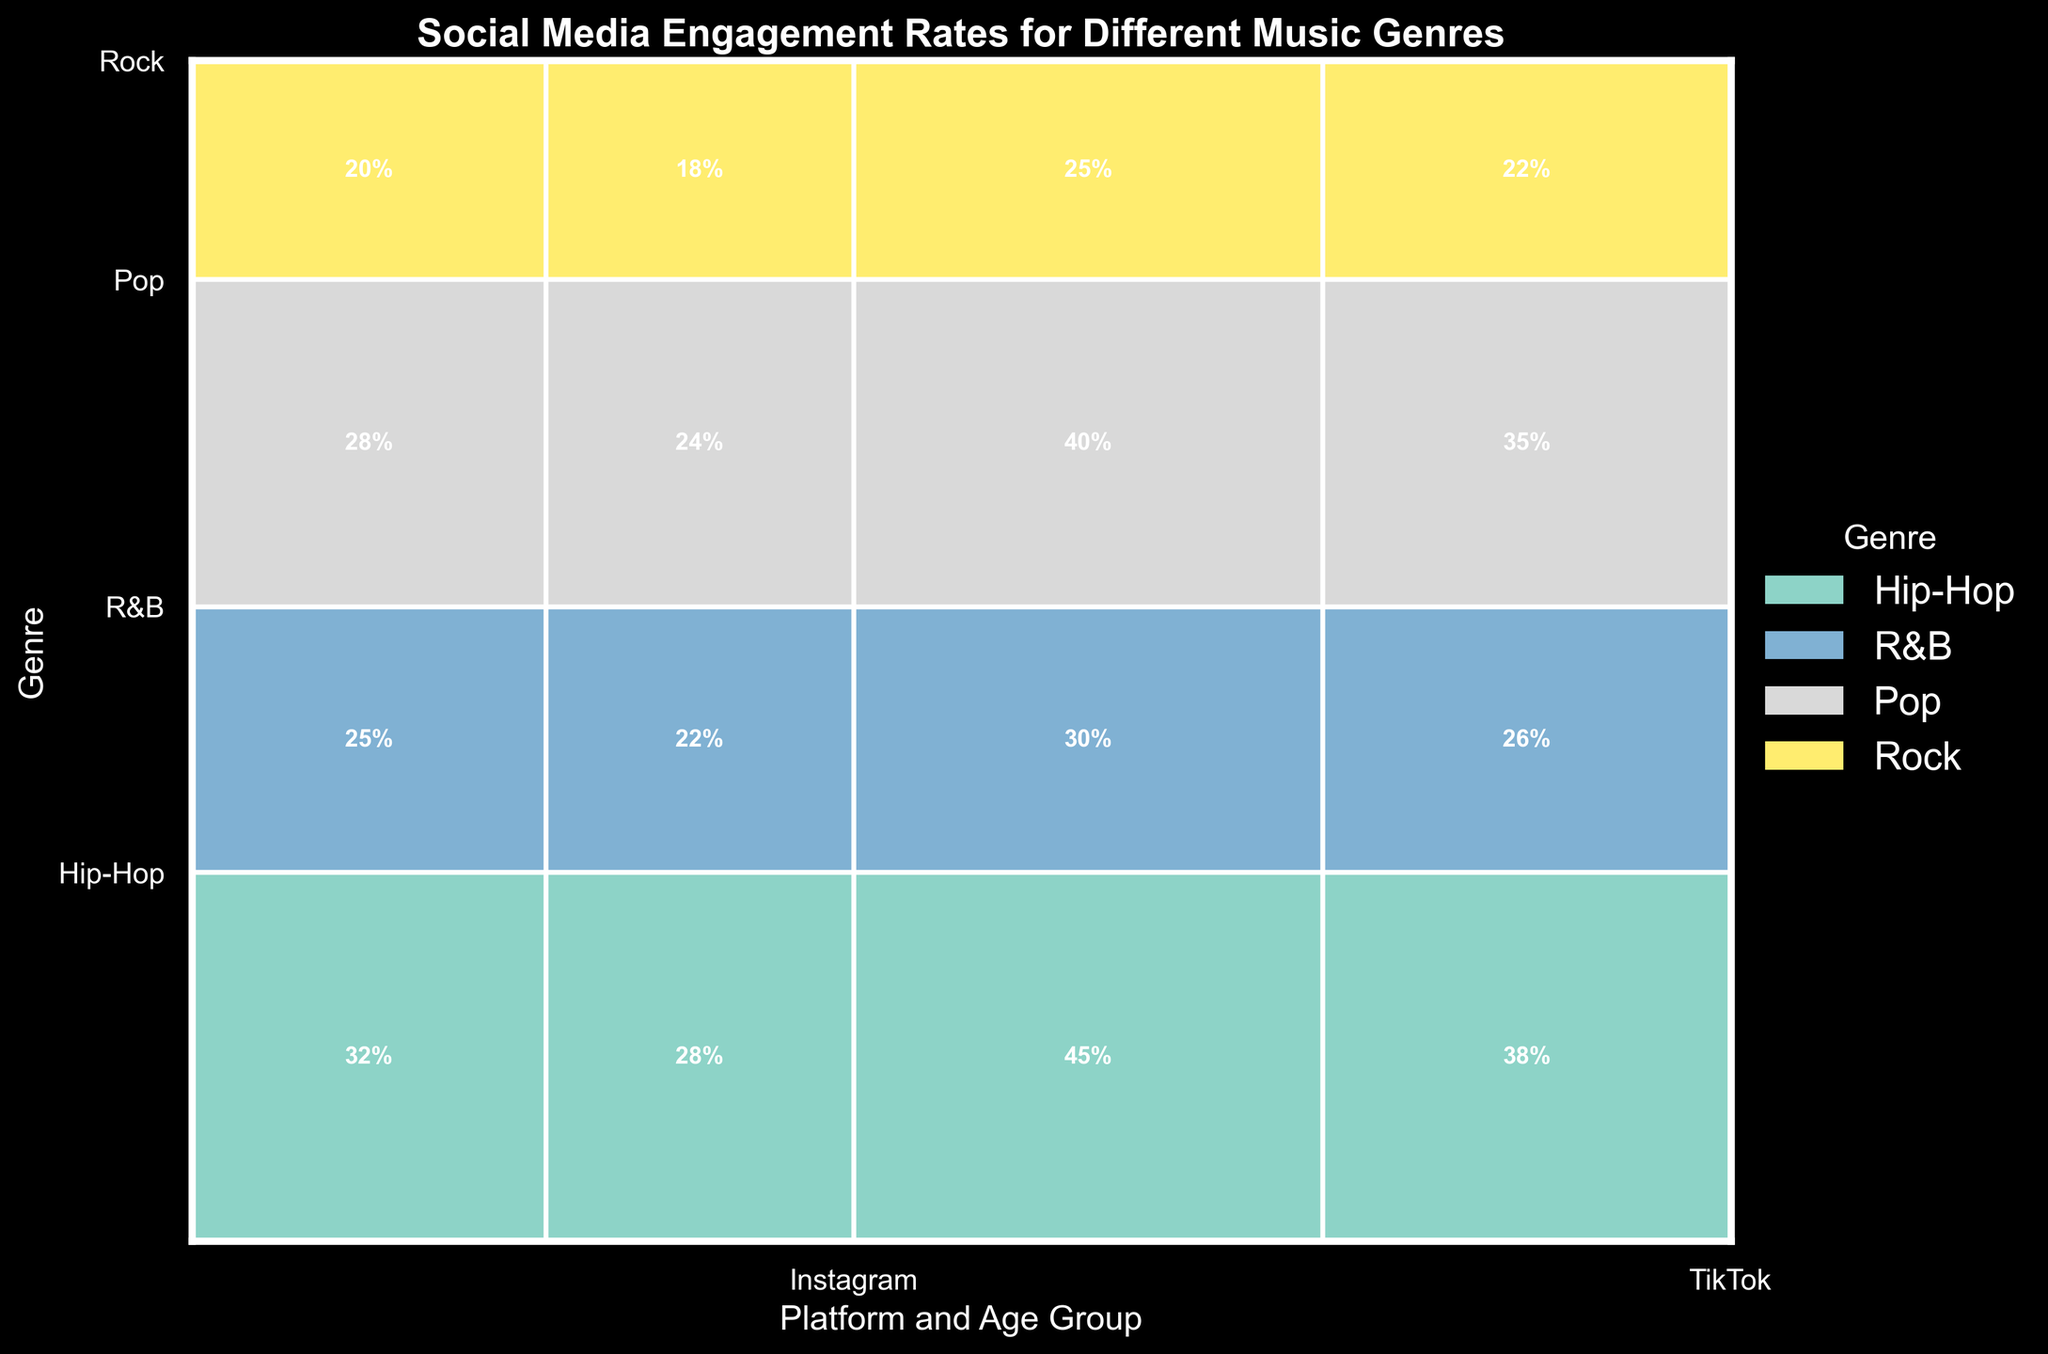Which music genre has the highest social media engagement rate on TikTok for the 18-24 age group? The TikTok engagement rates for the 18-24 age group can be found in the rectangles for each genre. Hip-Hop has 45%, R&B has 30%, Pop has 40%, and Rock has 25%. So, Hip-Hop has the highest engagement rate.
Answer: Hip-Hop Which platform has a higher engagement rate for Pop music, Instagram or TikTok? Examine the engagement rates for Pop music on both platforms. On Instagram, the rates are 28% for 18-24 and 24% for 25-34. On TikTok, the rates are 40% for 18-24 and 35% for 25-34. Summing these up, TikTok totals 75% while Instagram totals 52%.
Answer: TikTok What is the combined engagement rate for the R&B genre on both platforms for the 25-34 age group? The engagement rate for R&B on Instagram for 25-34 is 22%. On TikTok, it’s 26%. Adding these rates together, 22% + 26% = 48%.
Answer: 48% Which genre shows the least engagement rate on Instagram for the 18-24 age group? Looking at Instagram engagement rates for the 18-24 age group, Hip-Hop is 32%, R&B is 25%, Pop is 28%, and Rock is 20%. Therefore, Rock has the lowest engagement rate.
Answer: Rock Among all genres, which age group has the highest combined engagement rate on TikTok? Sum the engagement rates for each age group on TikTok across all genres. For 18-24: Hip-Hop (45%) + R&B (30%) + Pop (40%) + Rock (25%) = 140%. For 25-34: Hip-Hop (38%) + R&B (26%) + Pop (35%) + Rock (22%) = 121%. Hence, the 18-24 age group has the highest combined rate.
Answer: 18-24 How does the engagement rate for Hip-Hop on Instagram compare between the 18-24 and 25-34 age groups? The engagement rate for Hip-Hop on Instagram is 32% for the 18-24 age group and 28% for the 25-34 age group. Therefore, the 18-24 group has a higher engagement rate by 4 percentage points.
Answer: 4% What proportion of the total engagement does the Pop genre contribute to on TikTok for the 18-24 age group? First, calculate the sum of engagement rates for all categories on TikTok for the 18-24 group. Hip-Hop (45%) + R&B (30%) + Pop (40%) + Rock (25%) = 140%. The Pop genre contributes 40% of this 140%, so 40/140 = 28.57%.
Answer: 28.57% What is the difference in engagement rates between Instagram and TikTok for the genre with the highest combined engagement rate? Identify the genre with the highest combined rate: Pop on TikTok (75%). For Pop, Instagram (18-24: 28%, 25-34: 24%) total is 52%; TikTok (40% + 35%) total is 75%. The difference is 75% - 52% = 23%.
Answer: 23% 